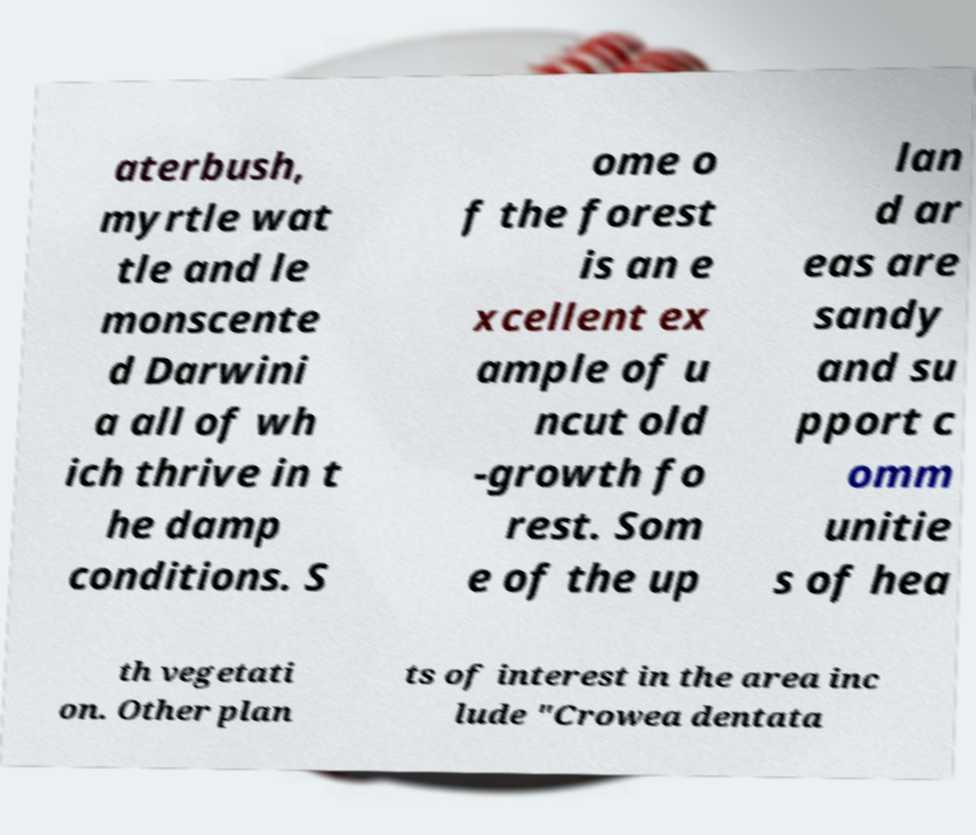Can you accurately transcribe the text from the provided image for me? aterbush, myrtle wat tle and le monscente d Darwini a all of wh ich thrive in t he damp conditions. S ome o f the forest is an e xcellent ex ample of u ncut old -growth fo rest. Som e of the up lan d ar eas are sandy and su pport c omm unitie s of hea th vegetati on. Other plan ts of interest in the area inc lude "Crowea dentata 